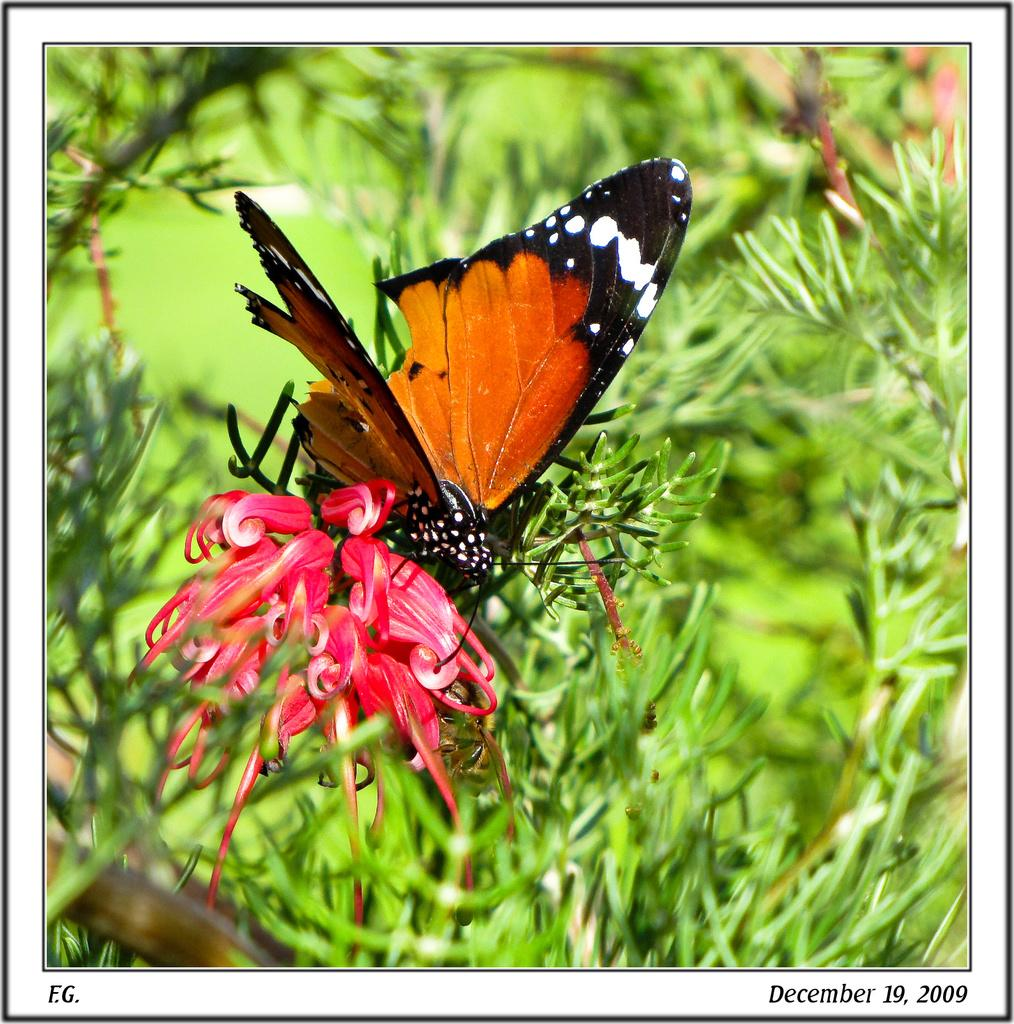What type of animal can be seen in the image? There is a butterfly in the image. What other living organisms are present in the image? There are plants and flowers in the image. Is there any text in the image? Yes, there is text at the bottom of the image. Can you tell me which arm the snail is using to climb the flower in the image? There is no snail present in the image, so it is not possible to determine which arm it might be using to climb the flower. 